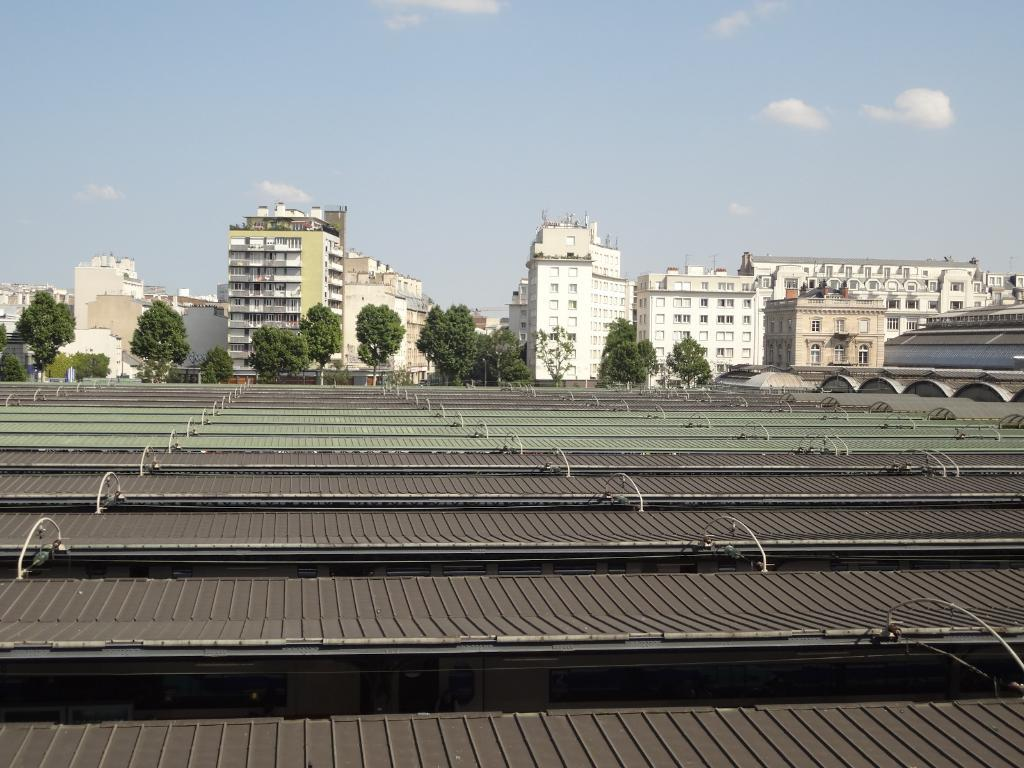What material is used for the sheets at the bottom of the image? Metal sheets are present at the bottom of the image. What can be seen in the background of the image? There are trees and buildings in the background of the image. What is the condition of the sky in the image? The sky is cloudy at the top of the image. How many crows are sitting on the metal sheets in the image? There are no crows present in the image; it only features metal sheets, trees, buildings, and a cloudy sky. What type of rod is being used to support the trees in the image? There is no rod visible in the image; the trees are standing on their own. 